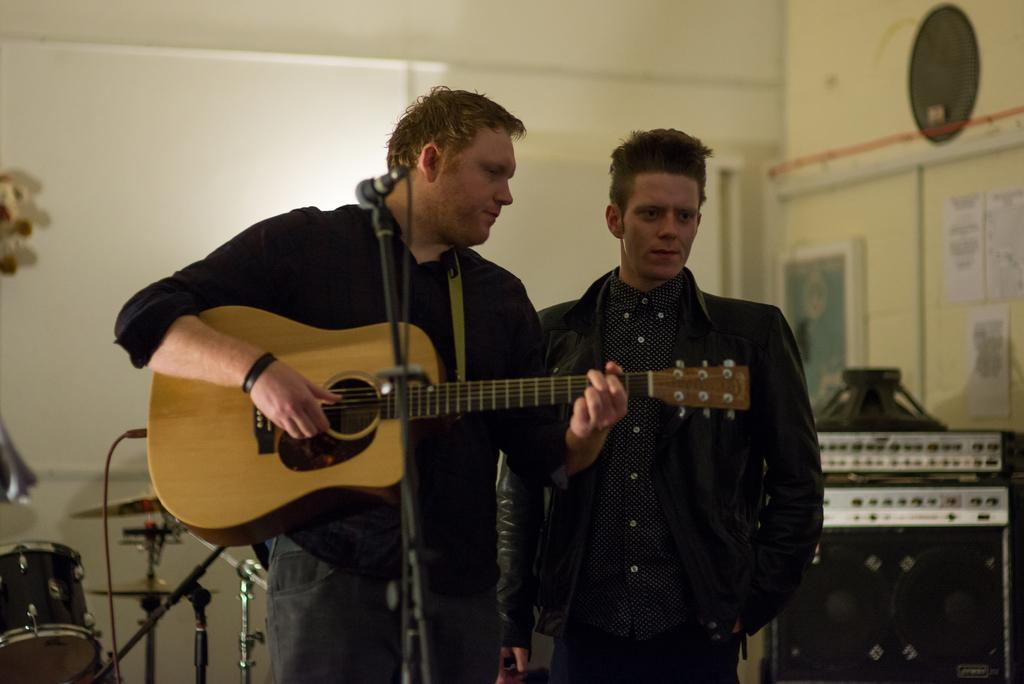What is the man in the image holding? The man is holding a guitar. Can you describe the position of the second man in the image? The second man is standing beside the first man. How many people are present in the image? There are two people in the image. What type of drink is the man holding in the image? There is no drink present in the image; the man is holding a guitar. How many arms does the guitar have in the image? The guitar does not have arms; it is an inanimate object. 